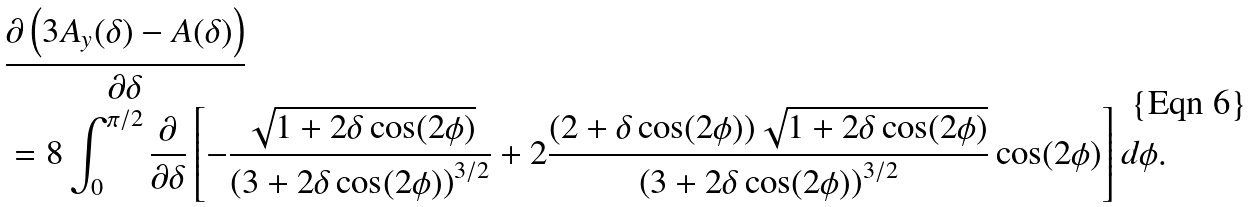Convert formula to latex. <formula><loc_0><loc_0><loc_500><loc_500>& \frac { \partial \left ( 3 A _ { y } ( \delta ) - A ( \delta ) \right ) } { \partial \delta } \\ & = 8 \int _ { 0 } ^ { \pi / 2 } \frac { \partial } { \partial \delta } \left [ - \frac { \sqrt { 1 + 2 \delta \cos ( 2 \phi ) } } { \left ( 3 + 2 \delta \cos ( 2 \phi ) \right ) ^ { 3 / 2 } } + 2 \frac { ( 2 + \delta \cos ( 2 \phi ) ) \sqrt { 1 + 2 \delta \cos ( 2 \phi ) } } { \left ( 3 + 2 \delta \cos ( 2 \phi ) \right ) ^ { 3 / 2 } } \cos ( 2 \phi ) \right ] d \phi .</formula> 